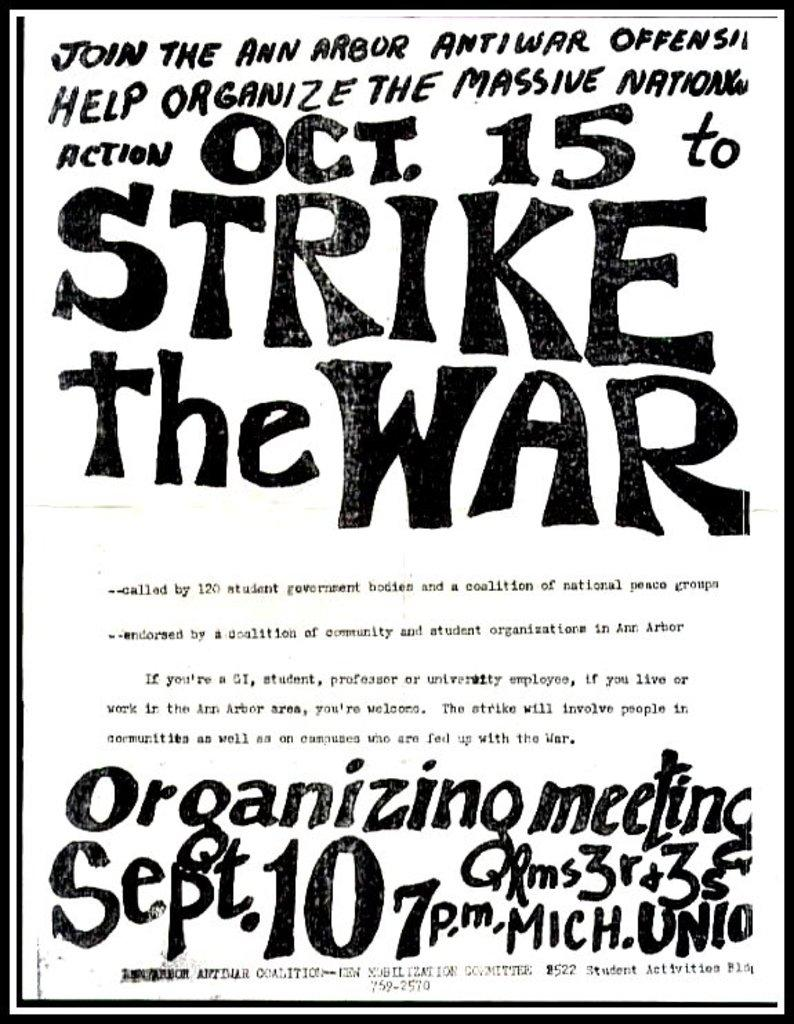<image>
Present a compact description of the photo's key features. a b&w poster for Ann Arbor's Oct 15th Strike the War 